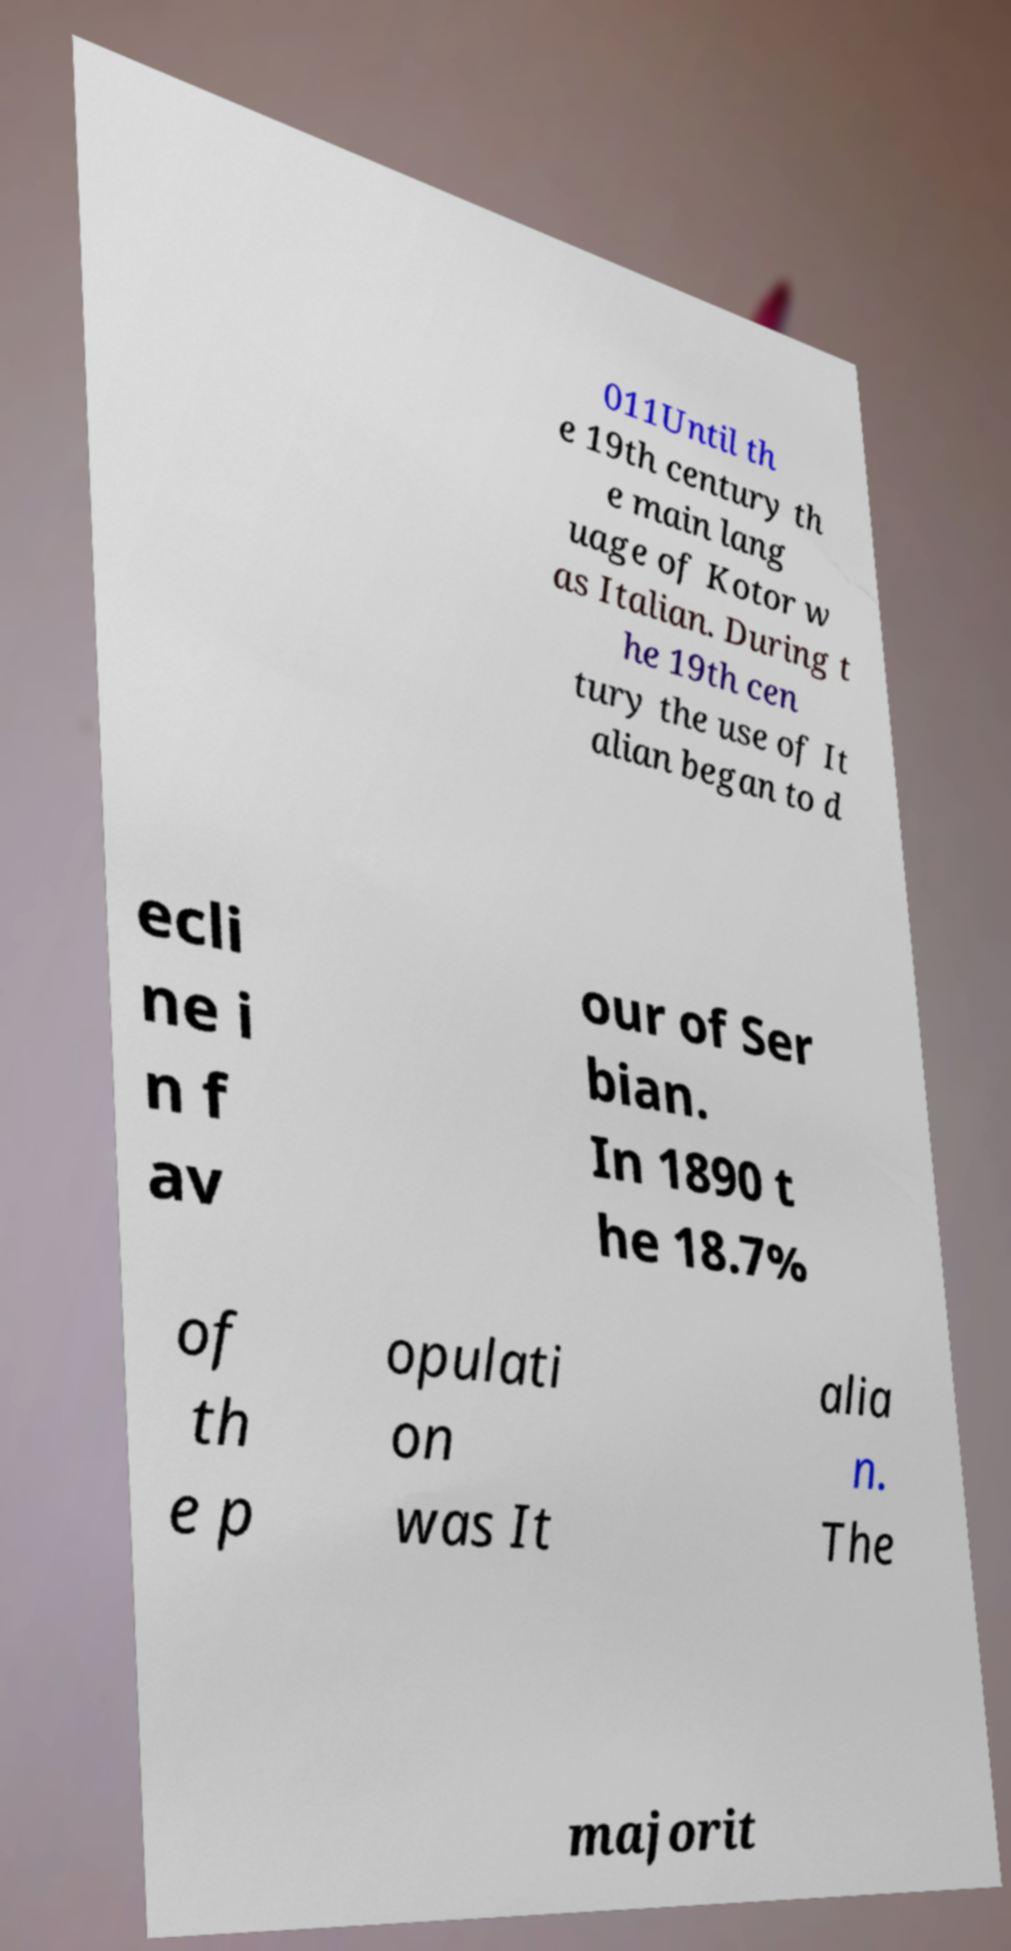Could you extract and type out the text from this image? 011Until th e 19th century th e main lang uage of Kotor w as Italian. During t he 19th cen tury the use of It alian began to d ecli ne i n f av our of Ser bian. In 1890 t he 18.7% of th e p opulati on was It alia n. The majorit 